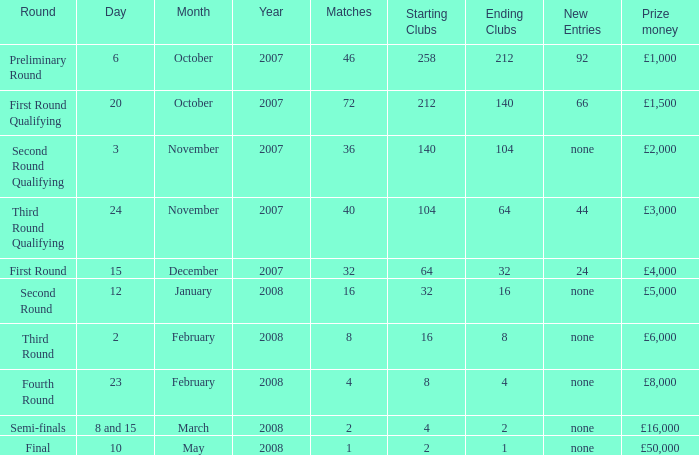What are the organizations with 46 matches? 258 → 212. 